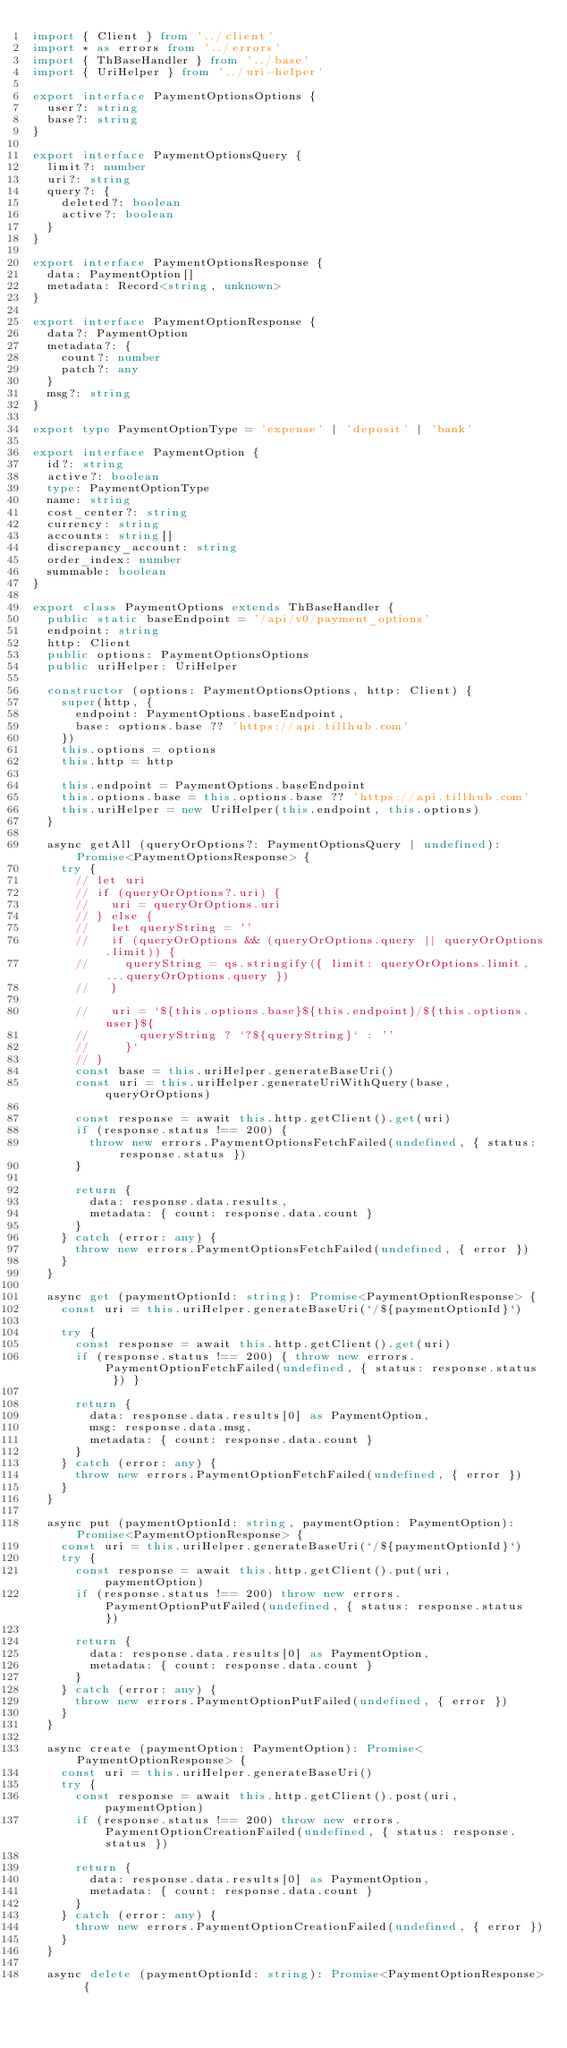<code> <loc_0><loc_0><loc_500><loc_500><_TypeScript_>import { Client } from '../client'
import * as errors from '../errors'
import { ThBaseHandler } from '../base'
import { UriHelper } from '../uri-helper'

export interface PaymentOptionsOptions {
  user?: string
  base?: string
}

export interface PaymentOptionsQuery {
  limit?: number
  uri?: string
  query?: {
    deleted?: boolean
    active?: boolean
  }
}

export interface PaymentOptionsResponse {
  data: PaymentOption[]
  metadata: Record<string, unknown>
}

export interface PaymentOptionResponse {
  data?: PaymentOption
  metadata?: {
    count?: number
    patch?: any
  }
  msg?: string
}

export type PaymentOptionType = 'expense' | 'deposit' | 'bank'

export interface PaymentOption {
  id?: string
  active?: boolean
  type: PaymentOptionType
  name: string
  cost_center?: string
  currency: string
  accounts: string[]
  discrepancy_account: string
  order_index: number
  summable: boolean
}

export class PaymentOptions extends ThBaseHandler {
  public static baseEndpoint = '/api/v0/payment_options'
  endpoint: string
  http: Client
  public options: PaymentOptionsOptions
  public uriHelper: UriHelper

  constructor (options: PaymentOptionsOptions, http: Client) {
    super(http, {
      endpoint: PaymentOptions.baseEndpoint,
      base: options.base ?? 'https://api.tillhub.com'
    })
    this.options = options
    this.http = http

    this.endpoint = PaymentOptions.baseEndpoint
    this.options.base = this.options.base ?? 'https://api.tillhub.com'
    this.uriHelper = new UriHelper(this.endpoint, this.options)
  }

  async getAll (queryOrOptions?: PaymentOptionsQuery | undefined): Promise<PaymentOptionsResponse> {
    try {
      // let uri
      // if (queryOrOptions?.uri) {
      //   uri = queryOrOptions.uri
      // } else {
      //   let queryString = ''
      //   if (queryOrOptions && (queryOrOptions.query || queryOrOptions.limit)) {
      //     queryString = qs.stringify({ limit: queryOrOptions.limit, ...queryOrOptions.query })
      //   }

      //   uri = `${this.options.base}${this.endpoint}/${this.options.user}${
      //       queryString ? `?${queryString}` : ''
      //     }`
      // }
      const base = this.uriHelper.generateBaseUri()
      const uri = this.uriHelper.generateUriWithQuery(base, queryOrOptions)

      const response = await this.http.getClient().get(uri)
      if (response.status !== 200) {
        throw new errors.PaymentOptionsFetchFailed(undefined, { status: response.status })
      }

      return {
        data: response.data.results,
        metadata: { count: response.data.count }
      }
    } catch (error: any) {
      throw new errors.PaymentOptionsFetchFailed(undefined, { error })
    }
  }

  async get (paymentOptionId: string): Promise<PaymentOptionResponse> {
    const uri = this.uriHelper.generateBaseUri(`/${paymentOptionId}`)

    try {
      const response = await this.http.getClient().get(uri)
      if (response.status !== 200) { throw new errors.PaymentOptionFetchFailed(undefined, { status: response.status }) }

      return {
        data: response.data.results[0] as PaymentOption,
        msg: response.data.msg,
        metadata: { count: response.data.count }
      }
    } catch (error: any) {
      throw new errors.PaymentOptionFetchFailed(undefined, { error })
    }
  }

  async put (paymentOptionId: string, paymentOption: PaymentOption): Promise<PaymentOptionResponse> {
    const uri = this.uriHelper.generateBaseUri(`/${paymentOptionId}`)
    try {
      const response = await this.http.getClient().put(uri, paymentOption)
      if (response.status !== 200) throw new errors.PaymentOptionPutFailed(undefined, { status: response.status })

      return {
        data: response.data.results[0] as PaymentOption,
        metadata: { count: response.data.count }
      }
    } catch (error: any) {
      throw new errors.PaymentOptionPutFailed(undefined, { error })
    }
  }

  async create (paymentOption: PaymentOption): Promise<PaymentOptionResponse> {
    const uri = this.uriHelper.generateBaseUri()
    try {
      const response = await this.http.getClient().post(uri, paymentOption)
      if (response.status !== 200) throw new errors.PaymentOptionCreationFailed(undefined, { status: response.status })

      return {
        data: response.data.results[0] as PaymentOption,
        metadata: { count: response.data.count }
      }
    } catch (error: any) {
      throw new errors.PaymentOptionCreationFailed(undefined, { error })
    }
  }

  async delete (paymentOptionId: string): Promise<PaymentOptionResponse> {</code> 